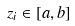Convert formula to latex. <formula><loc_0><loc_0><loc_500><loc_500>z _ { i } \in [ a , b ]</formula> 